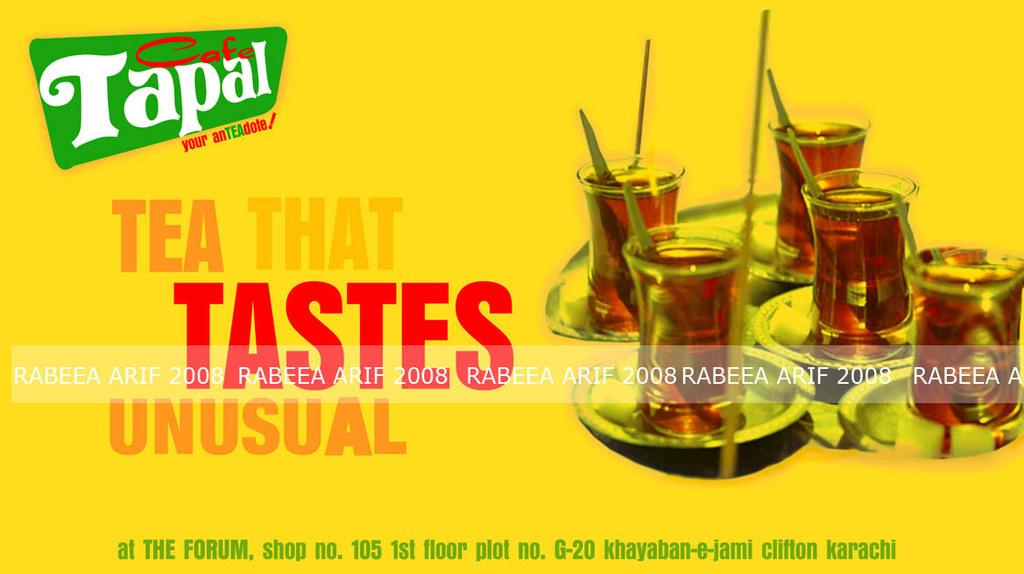What color is the poster in the image? The poster in the image is yellow. What is shown on the yellow poster? There are glasses depicted on the poster. Are there any words or letters on the poster? Yes, there is text on the poster. What type of zinc material is used to make the glasses on the poster? There is no information about the material used to make the glasses on the poster, and zinc is not mentioned in the facts provided. 